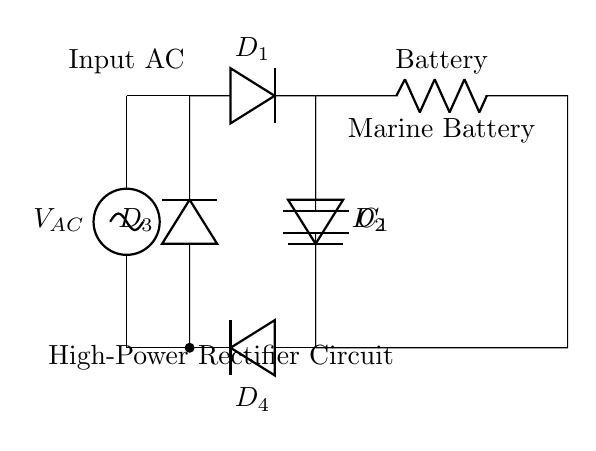What type of rectifier is shown in the circuit? The circuit diagram illustrates a bridge rectifier, characterized by the arrangement of four diodes that allow current to flow in one direction, converting AC voltage to DC voltage.
Answer: bridge rectifier What component smooths the output voltage? The capacitor, denoted as C1 in the diagram, is responsible for smoothing the output voltage by reducing voltage ripple after rectification, storing and releasing energy as needed.
Answer: capacitor How many diodes are used in the rectifier circuit? There are four diodes, labeled D1, D2, D3, and D4, connected in a bridge configuration to handle the rectification process efficiently.
Answer: four What is the purpose of the load resistor in this circuit? The load resistor, represented as the battery in the circuit, serves as the component that stores charge and provides power to the connected systems; it represents the marine battery being charged.
Answer: battery What type of current does this circuit convert to charging current? The circuit converts alternating current (AC) from the source into direct current (DC) suitable for charging the marine battery securely and efficiently.
Answer: alternating current Why is a smoothing capacitor necessary in this circuit? A smoothing capacitor is crucial as it filters out fluctuations in the rectified voltage, ensuring a more stable DC output, which is essential for proper battery charging without damage.
Answer: stable DC output 